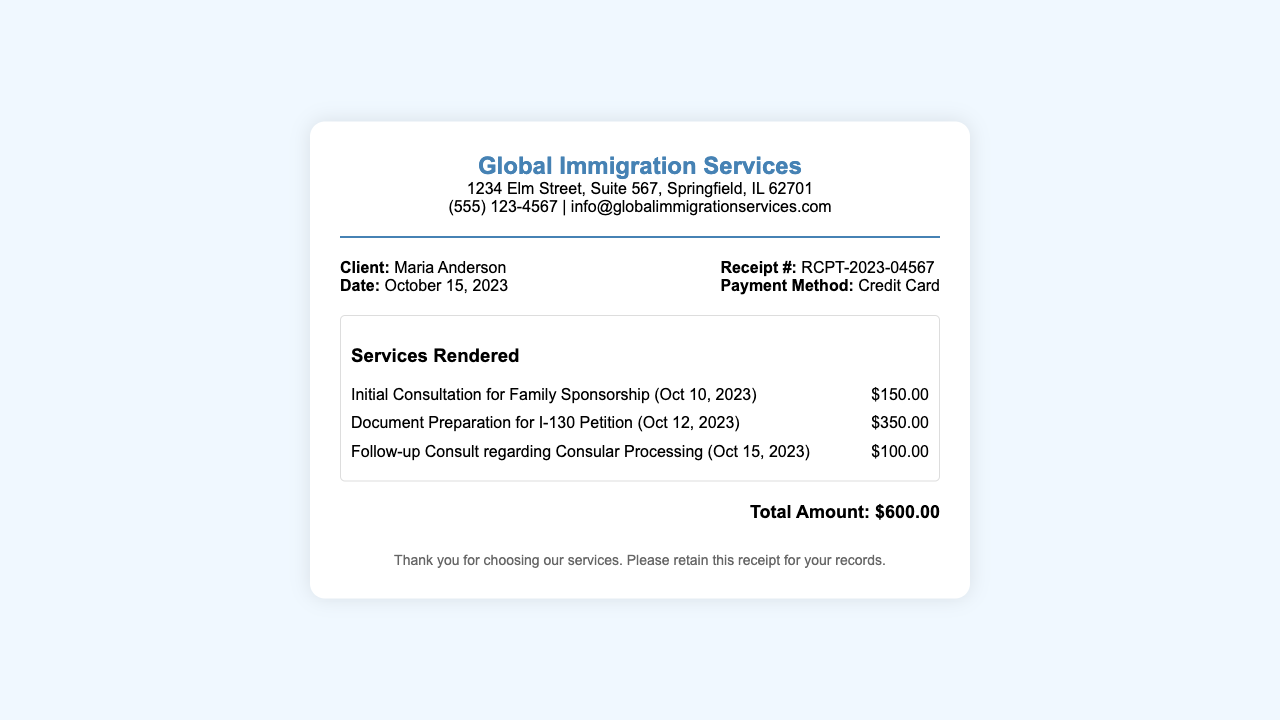What is the client's name? The client's name is listed at the top of the receipt under the client section.
Answer: Maria Anderson What is the date of the consultation? The date of the initial consultation for family sponsorship is provided in the services rendered section.
Answer: October 10, 2023 What is the total amount charged? The total amount is displayed prominently at the bottom of the receipt.
Answer: $600.00 What payment method was used? The payment method is specified in the receipt detail section on the right side.
Answer: Credit Card How much was charged for the I-130 Petition document preparation? The charge for the document preparation is listed alongside the service description in the services rendered section.
Answer: $350.00 What is the receipt number? The receipt number is displayed at the top right of the document under receipt details.
Answer: RCPT-2023-04567 How many services were rendered? The services rendered section lists three specific services in total.
Answer: Three What service was provided on October 15, 2023? The service provided on this date is listed within the dated services in the document.
Answer: Follow-up Consult regarding Consular Processing What is the address of the service provider? The address is included in the header section of the document.
Answer: 1234 Elm Street, Suite 567, Springfield, IL 62701 